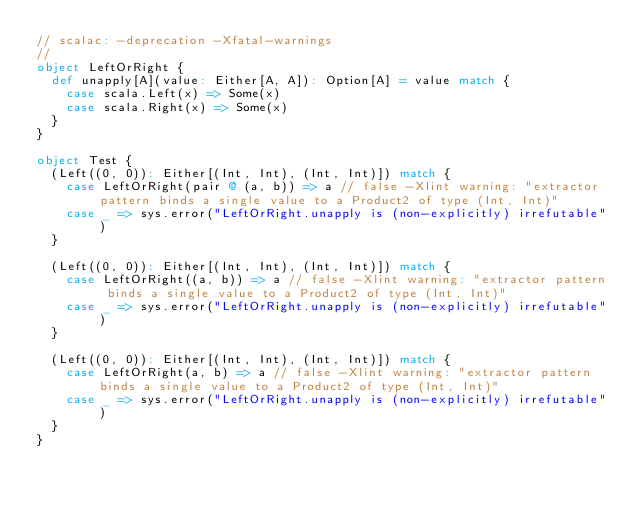Convert code to text. <code><loc_0><loc_0><loc_500><loc_500><_Scala_>// scalac: -deprecation -Xfatal-warnings
//
object LeftOrRight {
  def unapply[A](value: Either[A, A]): Option[A] = value match {
    case scala.Left(x) => Some(x)
    case scala.Right(x) => Some(x)
  }
}

object Test {
  (Left((0, 0)): Either[(Int, Int), (Int, Int)]) match {
    case LeftOrRight(pair @ (a, b)) => a // false -Xlint warning: "extractor pattern binds a single value to a Product2 of type (Int, Int)"
    case _ => sys.error("LeftOrRight.unapply is (non-explicitly) irrefutable")
  }

  (Left((0, 0)): Either[(Int, Int), (Int, Int)]) match {
    case LeftOrRight((a, b)) => a // false -Xlint warning: "extractor pattern binds a single value to a Product2 of type (Int, Int)"
    case _ => sys.error("LeftOrRight.unapply is (non-explicitly) irrefutable")
  }

  (Left((0, 0)): Either[(Int, Int), (Int, Int)]) match {
    case LeftOrRight(a, b) => a // false -Xlint warning: "extractor pattern binds a single value to a Product2 of type (Int, Int)"
    case _ => sys.error("LeftOrRight.unapply is (non-explicitly) irrefutable")
  }
}
</code> 